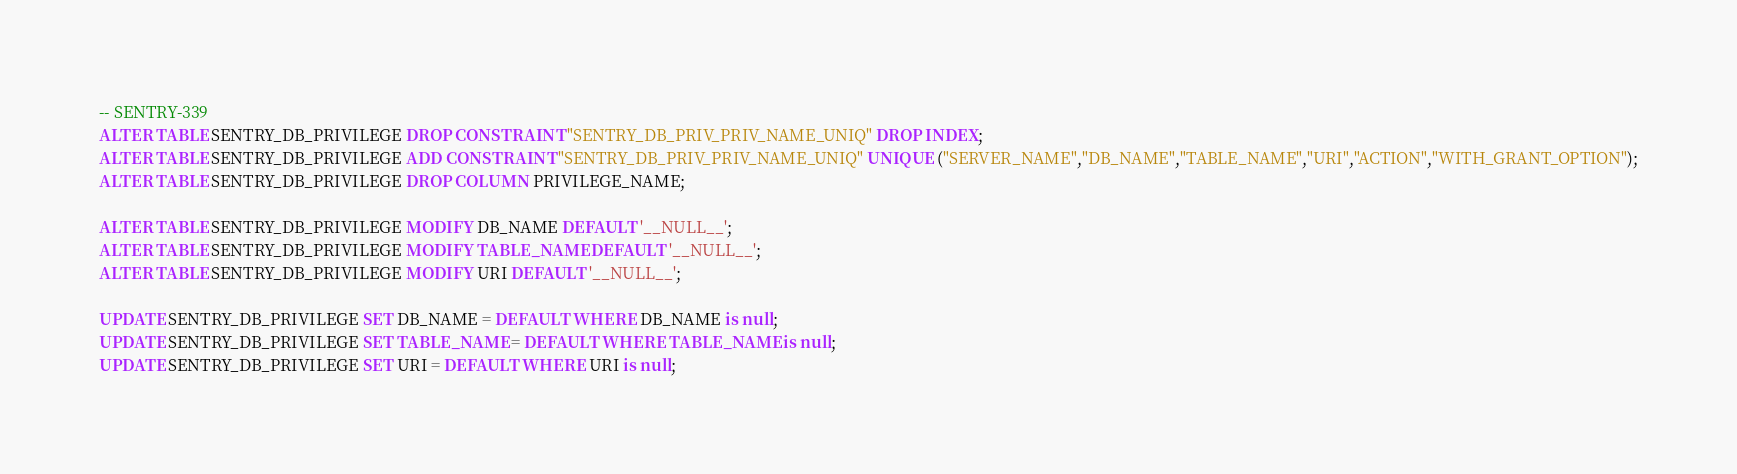<code> <loc_0><loc_0><loc_500><loc_500><_SQL_>-- SENTRY-339
ALTER TABLE SENTRY_DB_PRIVILEGE DROP CONSTRAINT "SENTRY_DB_PRIV_PRIV_NAME_UNIQ" DROP INDEX;
ALTER TABLE SENTRY_DB_PRIVILEGE ADD CONSTRAINT "SENTRY_DB_PRIV_PRIV_NAME_UNIQ" UNIQUE ("SERVER_NAME","DB_NAME","TABLE_NAME","URI","ACTION","WITH_GRANT_OPTION");
ALTER TABLE SENTRY_DB_PRIVILEGE DROP COLUMN PRIVILEGE_NAME;

ALTER TABLE SENTRY_DB_PRIVILEGE MODIFY DB_NAME DEFAULT '__NULL__';
ALTER TABLE SENTRY_DB_PRIVILEGE MODIFY TABLE_NAME DEFAULT '__NULL__';
ALTER TABLE SENTRY_DB_PRIVILEGE MODIFY URI DEFAULT '__NULL__';

UPDATE SENTRY_DB_PRIVILEGE SET DB_NAME = DEFAULT WHERE DB_NAME is null;
UPDATE SENTRY_DB_PRIVILEGE SET TABLE_NAME = DEFAULT WHERE TABLE_NAME is null;
UPDATE SENTRY_DB_PRIVILEGE SET URI = DEFAULT WHERE URI is null;

</code> 